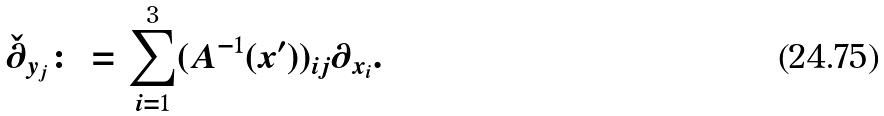<formula> <loc_0><loc_0><loc_500><loc_500>\check { \partial } _ { y _ { j } } \colon = \sum _ { i = 1 } ^ { 3 } ( A ^ { - 1 } ( x ^ { \prime } ) ) _ { i j } \partial _ { x _ { i } } .</formula> 